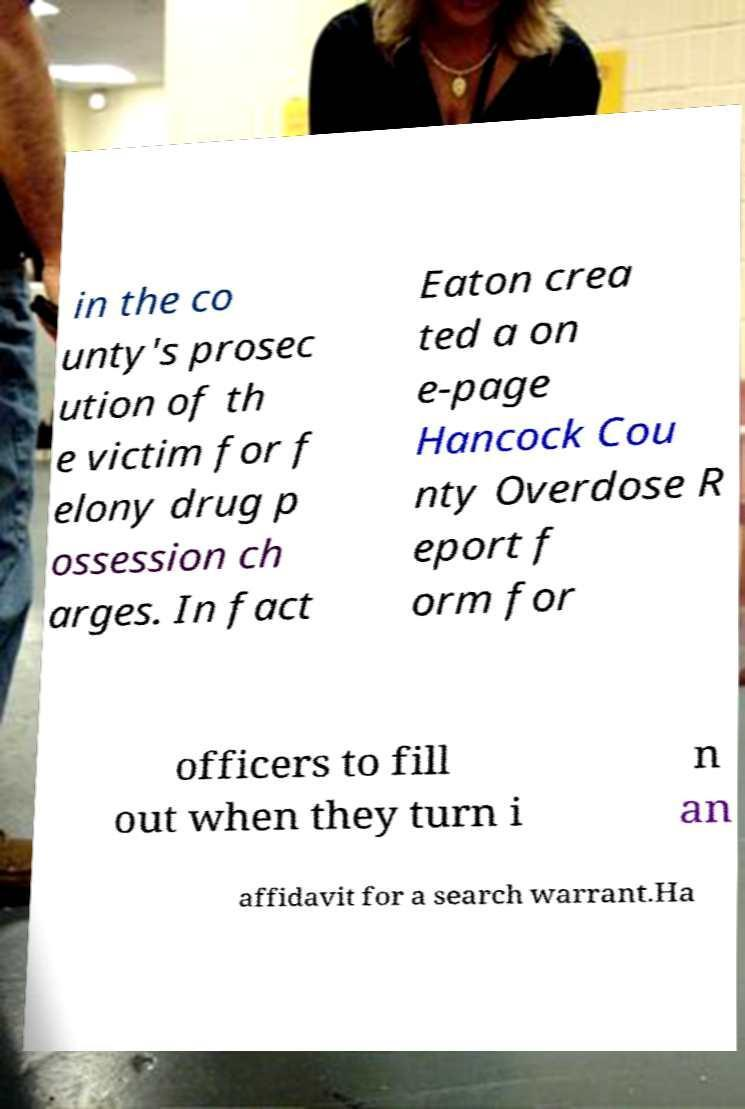Could you assist in decoding the text presented in this image and type it out clearly? in the co unty's prosec ution of th e victim for f elony drug p ossession ch arges. In fact Eaton crea ted a on e-page Hancock Cou nty Overdose R eport f orm for officers to fill out when they turn i n an affidavit for a search warrant.Ha 